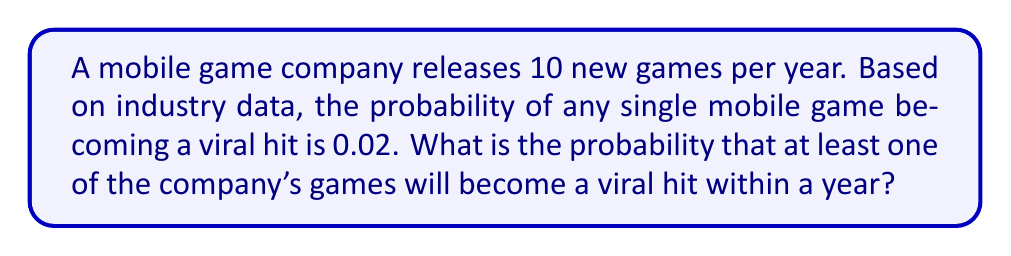Can you answer this question? Let's approach this step-by-step:

1) First, we need to calculate the probability of a game not becoming a viral hit. If the probability of success is 0.02, then the probability of failure is:

   $1 - 0.02 = 0.98$

2) Now, for all 10 games to not become viral hits, each game must fail. The probability of this happening is:

   $0.98^{10}$

3) Therefore, the probability of at least one game becoming a viral hit is the opposite of all games failing:

   $1 - 0.98^{10}$

4) Let's calculate this:

   $1 - 0.98^{10} = 1 - 0.8179 = 0.1821$

5) Converting to a percentage:

   $0.1821 \times 100 = 18.21\%$

Thus, there is approximately an 18.21% chance that at least one of the company's games will become a viral hit within a year.
Answer: 18.21% 